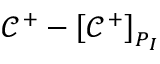Convert formula to latex. <formula><loc_0><loc_0><loc_500><loc_500>\mathcal { C } ^ { + } - \left [ \mathcal { C } ^ { + } \right ] _ { P _ { I } }</formula> 